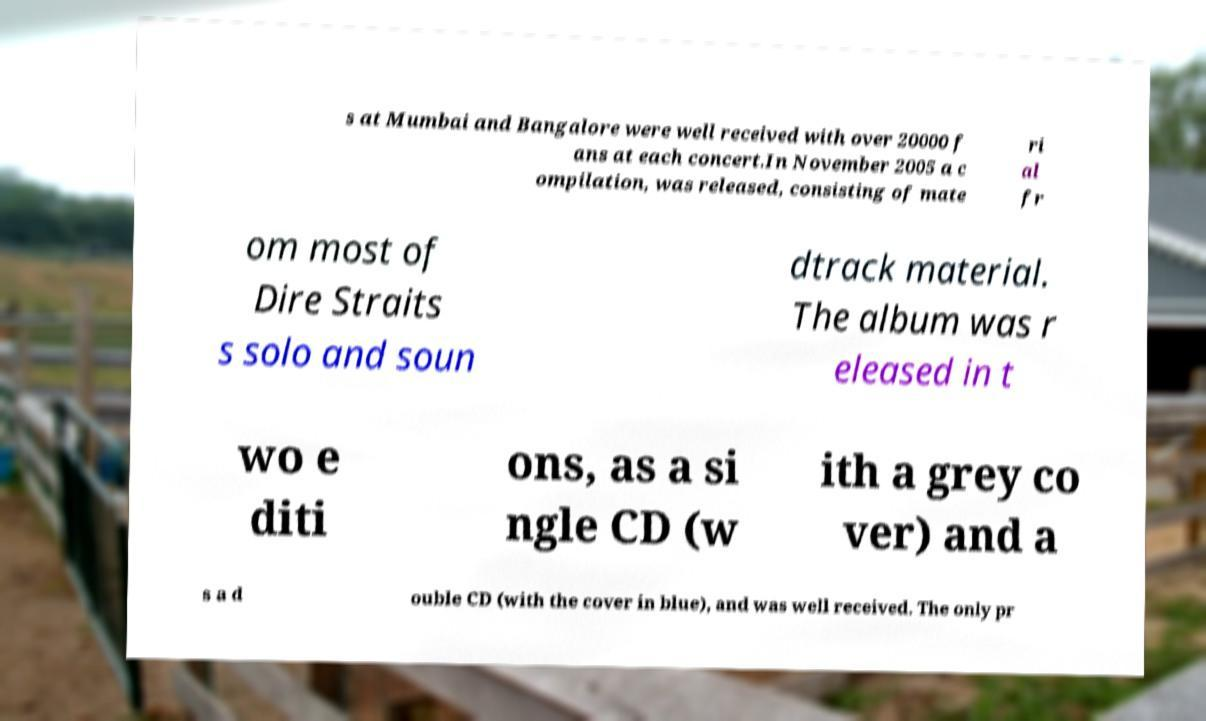Could you assist in decoding the text presented in this image and type it out clearly? s at Mumbai and Bangalore were well received with over 20000 f ans at each concert.In November 2005 a c ompilation, was released, consisting of mate ri al fr om most of Dire Straits s solo and soun dtrack material. The album was r eleased in t wo e diti ons, as a si ngle CD (w ith a grey co ver) and a s a d ouble CD (with the cover in blue), and was well received. The only pr 